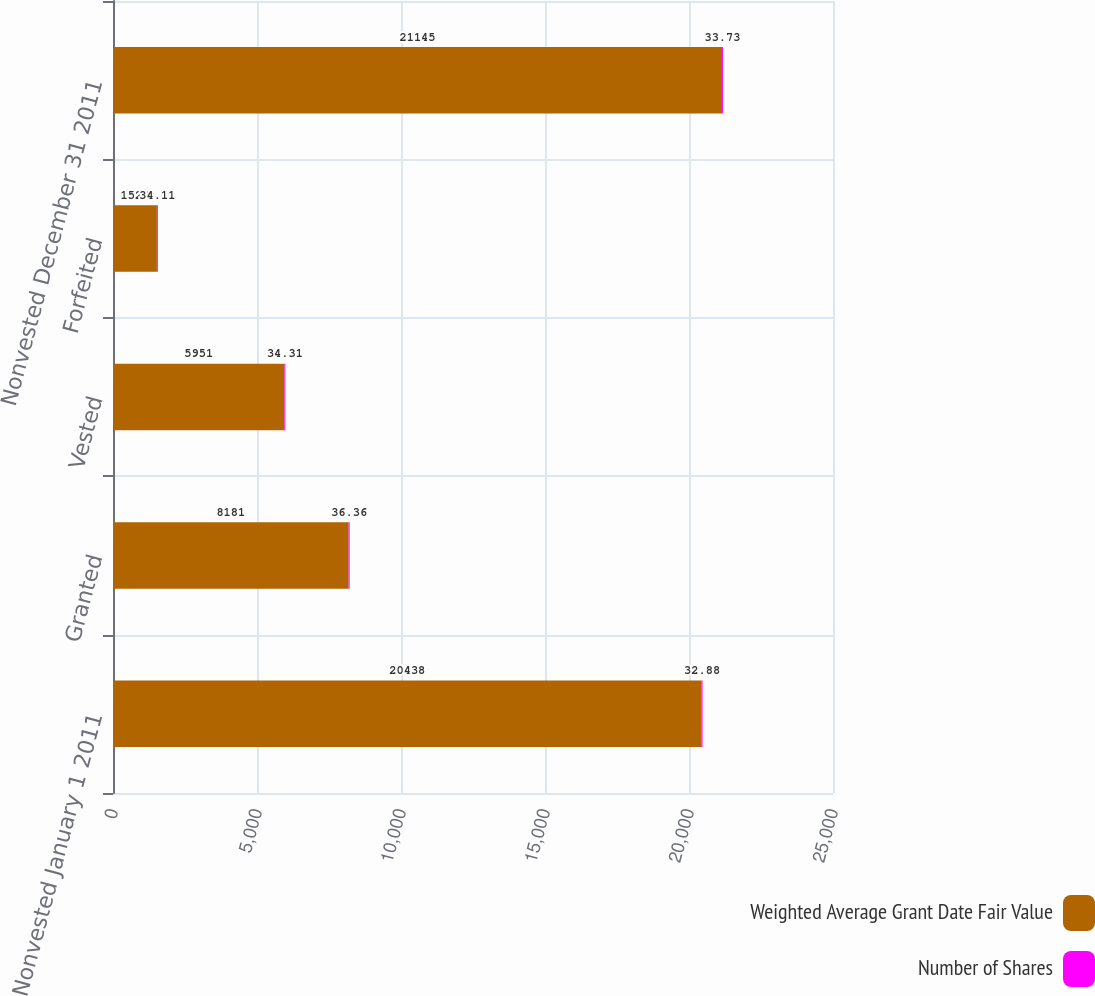Convert chart to OTSL. <chart><loc_0><loc_0><loc_500><loc_500><stacked_bar_chart><ecel><fcel>Nonvested January 1 2011<fcel>Granted<fcel>Vested<fcel>Forfeited<fcel>Nonvested December 31 2011<nl><fcel>Weighted Average Grant Date Fair Value<fcel>20438<fcel>8181<fcel>5951<fcel>1523<fcel>21145<nl><fcel>Number of Shares<fcel>32.88<fcel>36.36<fcel>34.31<fcel>34.11<fcel>33.73<nl></chart> 